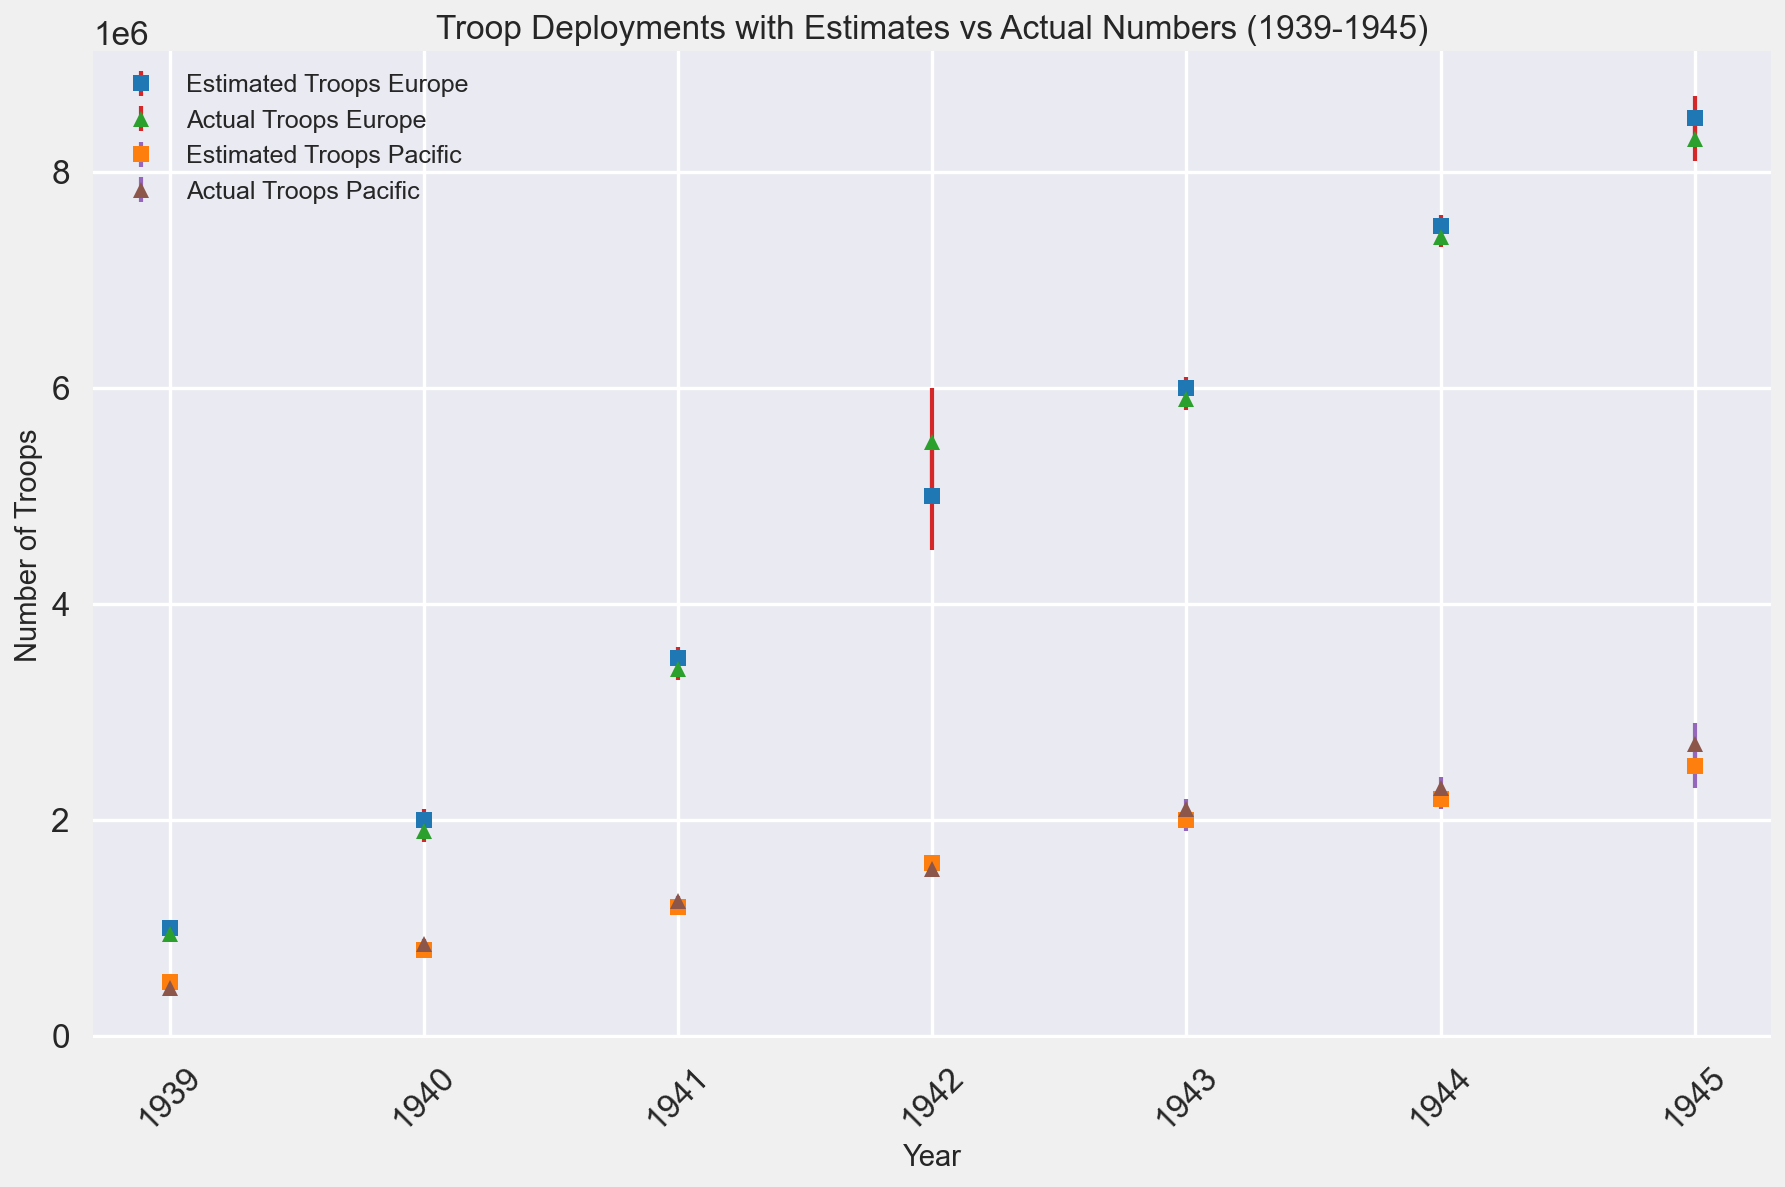How did the actual troops deployed in the European theatre compare to the estimated troops in 1942? The actual troops in the European theatre in 1942 were 5,500,000, while the estimated number was 5,000,000. This shows the actual deployment exceeded the estimate by 500,000 troops.
Answer: 500,000 more In 1945, was there a larger difference between estimated and actual troop numbers in the European or Pacific theatre? In 1945, the difference for the European theatre was 200,000 (8,500,000 estimated vs. 8,300,000 actual) and for the Pacific theatre it was 200,000 (2,500,000 estimated vs. 2,700,000 actual). The differences are equal, both being 200,000.
Answer: Equal What year saw the largest discrepancy between estimated and actual troop numbers in the European theatre? By checking each year, the largest discrepancy in the European theatre was in 1942, with a difference of 500,000 troops (estimated 5,000,000 vs. actual 5,500,000).
Answer: 1942 Between 1943 and 1944, by how much did the actual troop deployments in the Pacific theatre increase? In 1943, the actual troop count in the Pacific was 2,100,000, and in 1944, it was 2,300,000. The increase between these years is 200,000 troops.
Answer: 200,000 Which year had the smallest difference between estimated and actual troop deployments in the Pacific theatre? In 1941, the estimated troop numbers were 1,200,000, and the actual numbers were 1,250,000, giving a difference of 50,000, the smallest difference for the Pacific theatre across all the years.
Answer: 1941 What is the total number of troops deployed in Europe in 1940 considering both estimated and actual figures? In 1940, the estimated troops in Europe were 2,000,000 and the actual troops were 1,900,000. Adding them together gives 3,900,000 troops.
Answer: 3,900,000 Compare the trend of actual troop deployments over the years in the European theatre to the Pacific theatre. In the European theatre, actual troop deployments increased steadily from 950,000 in 1939 to 8,300,000 in 1945. Similarly, in the Pacific theatre, the actual deployments increased from 450,000 in 1939 to 2,700,000 in 1945. Both theatres show an upward trend, with Europe seeing a steeper increase.
Answer: Upward trend in both How does the error margin differ between the European and Pacific theatres in 1943? In 1943, the error margin for Europe is calculated by the difference between estimated (6,000,000) and actual (5,900,000), which is 100,000. For the Pacific, the difference between estimated (2,000,000) and actual (2,100,000) is also 100,000. Thus, the error margins are the same.
Answer: Same What are the visual indicators used to differentiate between estimated and actual troop numbers in the plot? The plot uses different colors and markers for estimated and actual troop numbers. Estimated values are indicated with square markers while actual values have triangle markers. The colors differ between Europe (blue for estimated, green for actual) and Pacific (orange for estimated, brown for actual). Error bars are in red for Europe and purple for Pacific.
Answer: Color and marker differences 